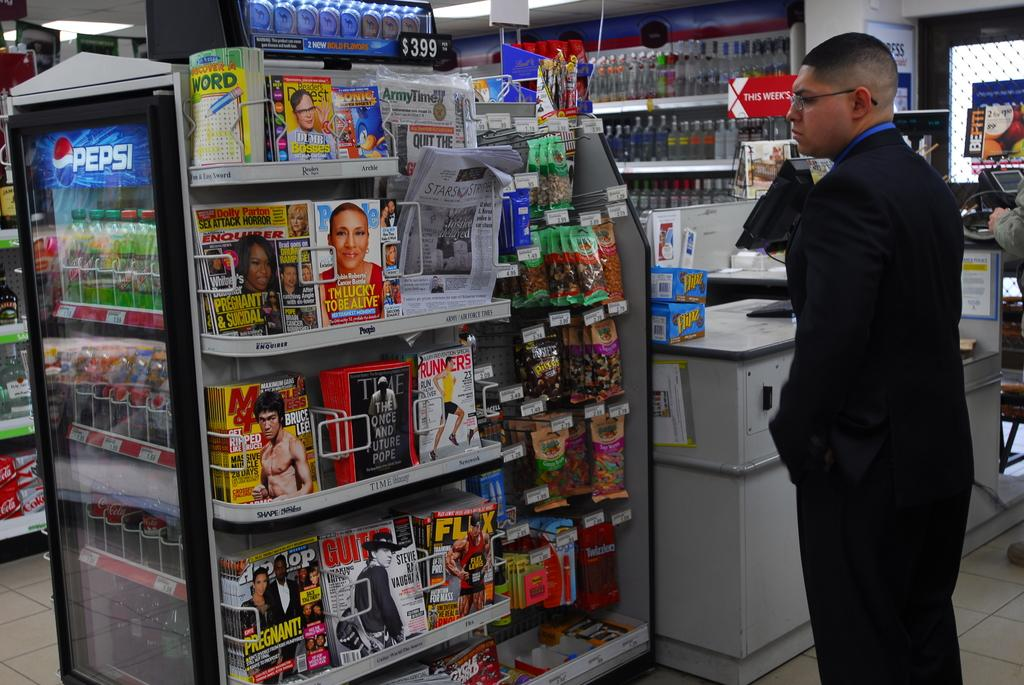<image>
Summarize the visual content of the image. Man looking at magazines including one that says BRUCE LEE on it. 